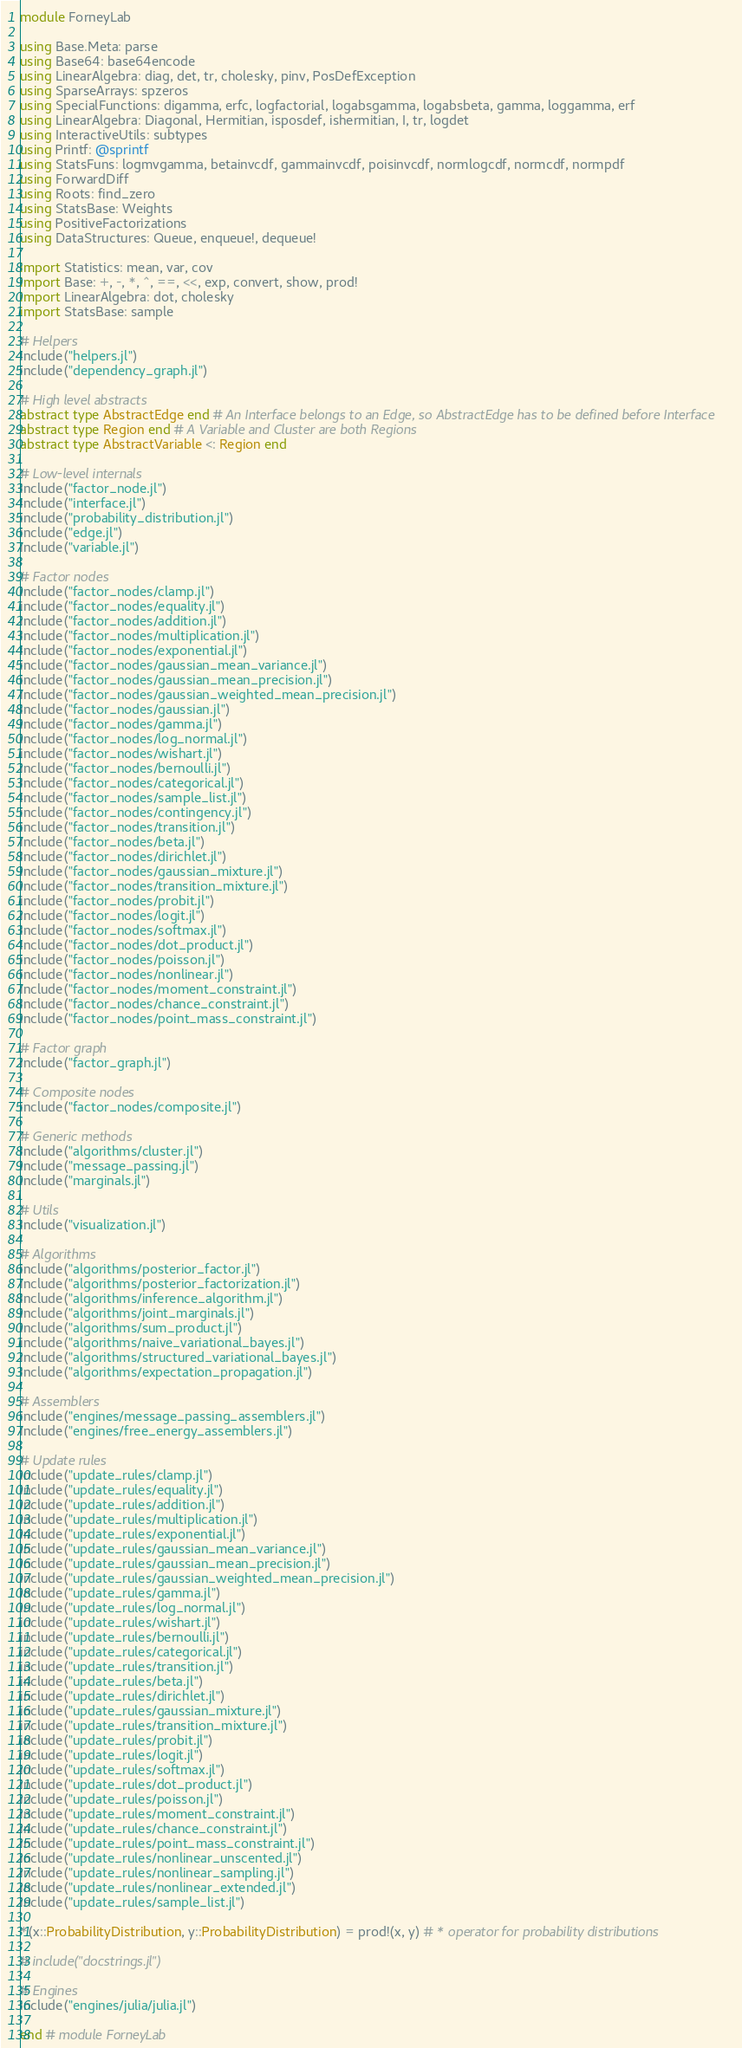<code> <loc_0><loc_0><loc_500><loc_500><_Julia_>module ForneyLab

using Base.Meta: parse
using Base64: base64encode
using LinearAlgebra: diag, det, tr, cholesky, pinv, PosDefException
using SparseArrays: spzeros
using SpecialFunctions: digamma, erfc, logfactorial, logabsgamma, logabsbeta, gamma, loggamma, erf
using LinearAlgebra: Diagonal, Hermitian, isposdef, ishermitian, I, tr, logdet
using InteractiveUtils: subtypes
using Printf: @sprintf
using StatsFuns: logmvgamma, betainvcdf, gammainvcdf, poisinvcdf, normlogcdf, normcdf, normpdf
using ForwardDiff
using Roots: find_zero
using StatsBase: Weights
using PositiveFactorizations
using DataStructures: Queue, enqueue!, dequeue!

import Statistics: mean, var, cov
import Base: +, -, *, ^, ==, <<, exp, convert, show, prod!
import LinearAlgebra: dot, cholesky
import StatsBase: sample

# Helpers
include("helpers.jl")
include("dependency_graph.jl")

# High level abstracts
abstract type AbstractEdge end # An Interface belongs to an Edge, so AbstractEdge has to be defined before Interface
abstract type Region end # A Variable and Cluster are both Regions
abstract type AbstractVariable <: Region end

# Low-level internals
include("factor_node.jl")
include("interface.jl")
include("probability_distribution.jl")
include("edge.jl")
include("variable.jl")

# Factor nodes
include("factor_nodes/clamp.jl")
include("factor_nodes/equality.jl")
include("factor_nodes/addition.jl")
include("factor_nodes/multiplication.jl")
include("factor_nodes/exponential.jl")
include("factor_nodes/gaussian_mean_variance.jl")
include("factor_nodes/gaussian_mean_precision.jl")
include("factor_nodes/gaussian_weighted_mean_precision.jl")
include("factor_nodes/gaussian.jl")
include("factor_nodes/gamma.jl")
include("factor_nodes/log_normal.jl")
include("factor_nodes/wishart.jl")
include("factor_nodes/bernoulli.jl")
include("factor_nodes/categorical.jl")
include("factor_nodes/sample_list.jl")
include("factor_nodes/contingency.jl")
include("factor_nodes/transition.jl")
include("factor_nodes/beta.jl")
include("factor_nodes/dirichlet.jl")
include("factor_nodes/gaussian_mixture.jl")
include("factor_nodes/transition_mixture.jl")
include("factor_nodes/probit.jl")
include("factor_nodes/logit.jl")
include("factor_nodes/softmax.jl")
include("factor_nodes/dot_product.jl")
include("factor_nodes/poisson.jl")
include("factor_nodes/nonlinear.jl")
include("factor_nodes/moment_constraint.jl")
include("factor_nodes/chance_constraint.jl")
include("factor_nodes/point_mass_constraint.jl")

# Factor graph
include("factor_graph.jl")

# Composite nodes
include("factor_nodes/composite.jl")

# Generic methods
include("algorithms/cluster.jl")
include("message_passing.jl")
include("marginals.jl")

# Utils
include("visualization.jl")

# Algorithms
include("algorithms/posterior_factor.jl")
include("algorithms/posterior_factorization.jl")
include("algorithms/inference_algorithm.jl")
include("algorithms/joint_marginals.jl")
include("algorithms/sum_product.jl")
include("algorithms/naive_variational_bayes.jl")
include("algorithms/structured_variational_bayes.jl")
include("algorithms/expectation_propagation.jl")

# Assemblers
include("engines/message_passing_assemblers.jl")
include("engines/free_energy_assemblers.jl")

# Update rules
include("update_rules/clamp.jl")
include("update_rules/equality.jl")
include("update_rules/addition.jl")
include("update_rules/multiplication.jl")
include("update_rules/exponential.jl")
include("update_rules/gaussian_mean_variance.jl")
include("update_rules/gaussian_mean_precision.jl")
include("update_rules/gaussian_weighted_mean_precision.jl")
include("update_rules/gamma.jl")
include("update_rules/log_normal.jl")
include("update_rules/wishart.jl")
include("update_rules/bernoulli.jl")
include("update_rules/categorical.jl")
include("update_rules/transition.jl")
include("update_rules/beta.jl")
include("update_rules/dirichlet.jl")
include("update_rules/gaussian_mixture.jl")
include("update_rules/transition_mixture.jl")
include("update_rules/probit.jl")
include("update_rules/logit.jl")
include("update_rules/softmax.jl")
include("update_rules/dot_product.jl")
include("update_rules/poisson.jl")
include("update_rules/moment_constraint.jl")
include("update_rules/chance_constraint.jl")
include("update_rules/point_mass_constraint.jl")
include("update_rules/nonlinear_unscented.jl")
include("update_rules/nonlinear_sampling.jl")
include("update_rules/nonlinear_extended.jl")
include("update_rules/sample_list.jl")

*(x::ProbabilityDistribution, y::ProbabilityDistribution) = prod!(x, y) # * operator for probability distributions

# include("docstrings.jl")

# Engines
include("engines/julia/julia.jl")

end # module ForneyLab
</code> 